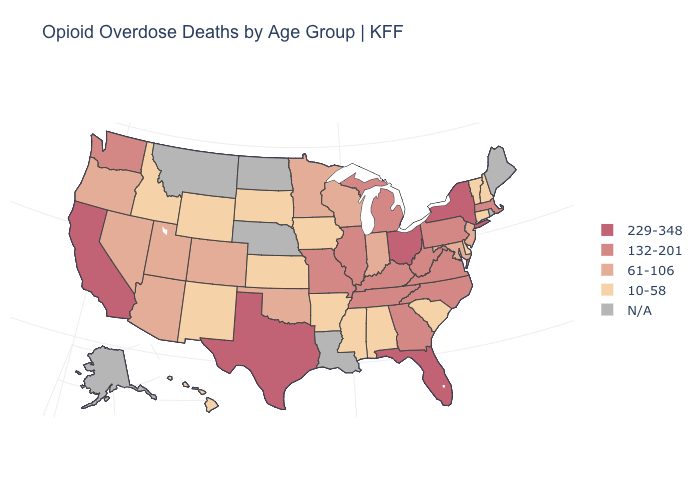Does the first symbol in the legend represent the smallest category?
Give a very brief answer. No. Is the legend a continuous bar?
Give a very brief answer. No. How many symbols are there in the legend?
Give a very brief answer. 5. What is the highest value in states that border Indiana?
Keep it brief. 229-348. Which states have the highest value in the USA?
Write a very short answer. California, Florida, New York, Ohio, Texas. What is the highest value in the MidWest ?
Write a very short answer. 229-348. Name the states that have a value in the range N/A?
Be succinct. Alaska, Louisiana, Maine, Montana, Nebraska, North Dakota, Rhode Island. Does Kansas have the lowest value in the USA?
Concise answer only. Yes. Does the map have missing data?
Concise answer only. Yes. Which states have the lowest value in the South?
Concise answer only. Alabama, Arkansas, Delaware, Mississippi, South Carolina. Does the first symbol in the legend represent the smallest category?
Give a very brief answer. No. Which states have the lowest value in the South?
Keep it brief. Alabama, Arkansas, Delaware, Mississippi, South Carolina. What is the lowest value in the USA?
Quick response, please. 10-58. Does Virginia have the lowest value in the USA?
Be succinct. No. 